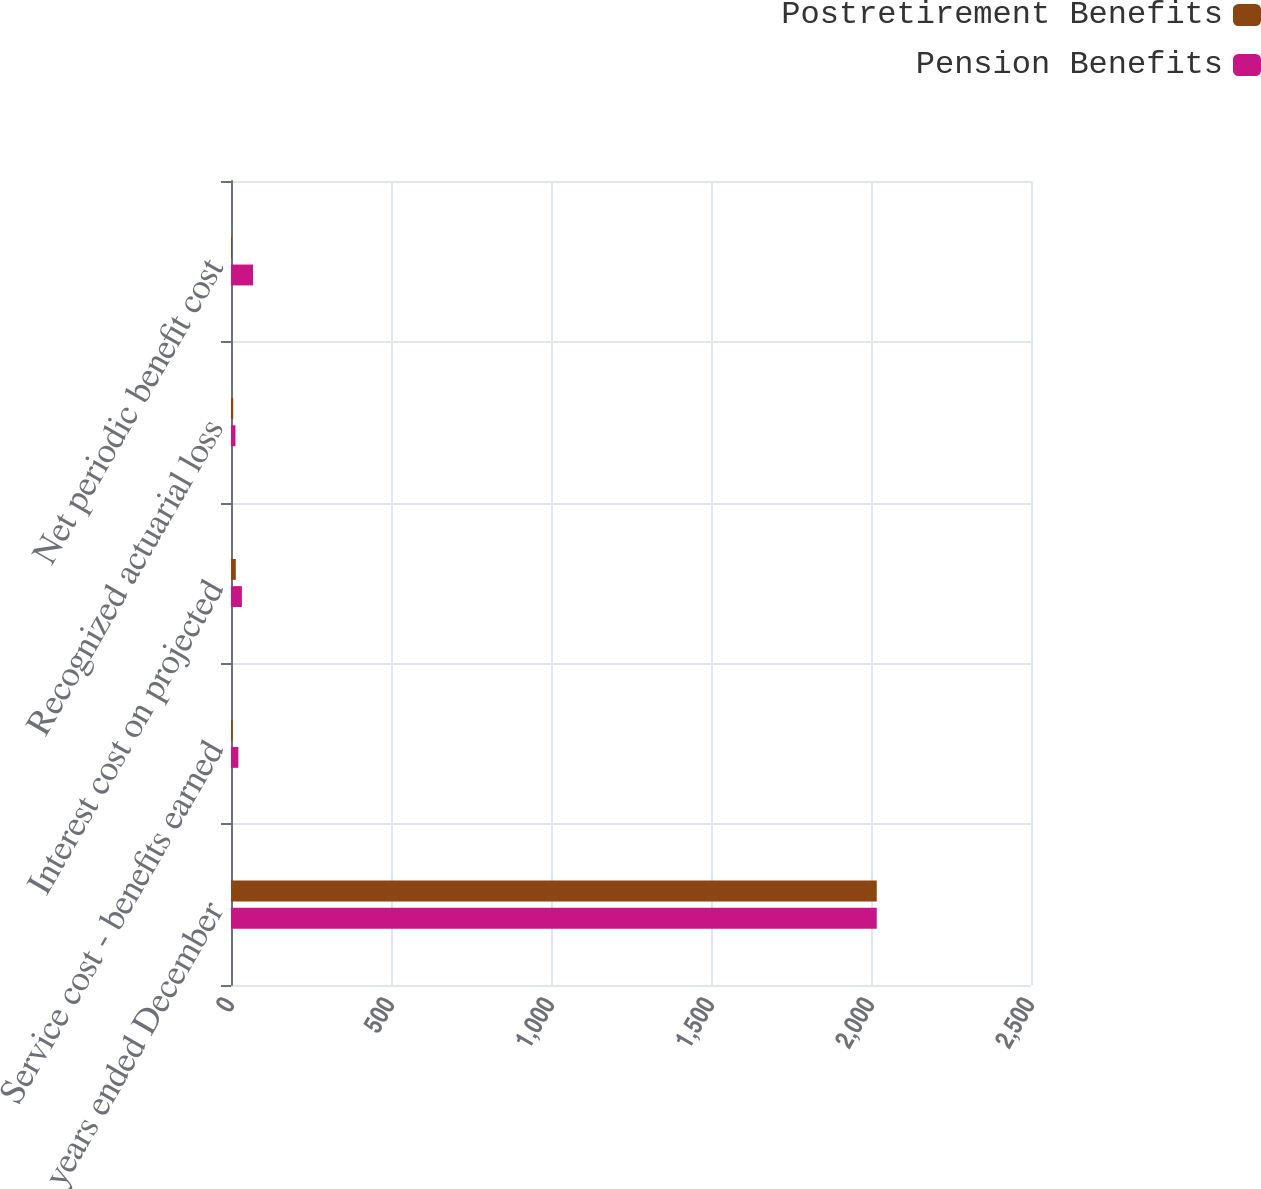<chart> <loc_0><loc_0><loc_500><loc_500><stacked_bar_chart><ecel><fcel>For the years ended December<fcel>Service cost - benefits earned<fcel>Interest cost on projected<fcel>Recognized actuarial loss<fcel>Net periodic benefit cost<nl><fcel>Postretirement Benefits<fcel>2018<fcel>5<fcel>15<fcel>7<fcel>3<nl><fcel>Pension Benefits<fcel>2018<fcel>23<fcel>34<fcel>14<fcel>69<nl></chart> 